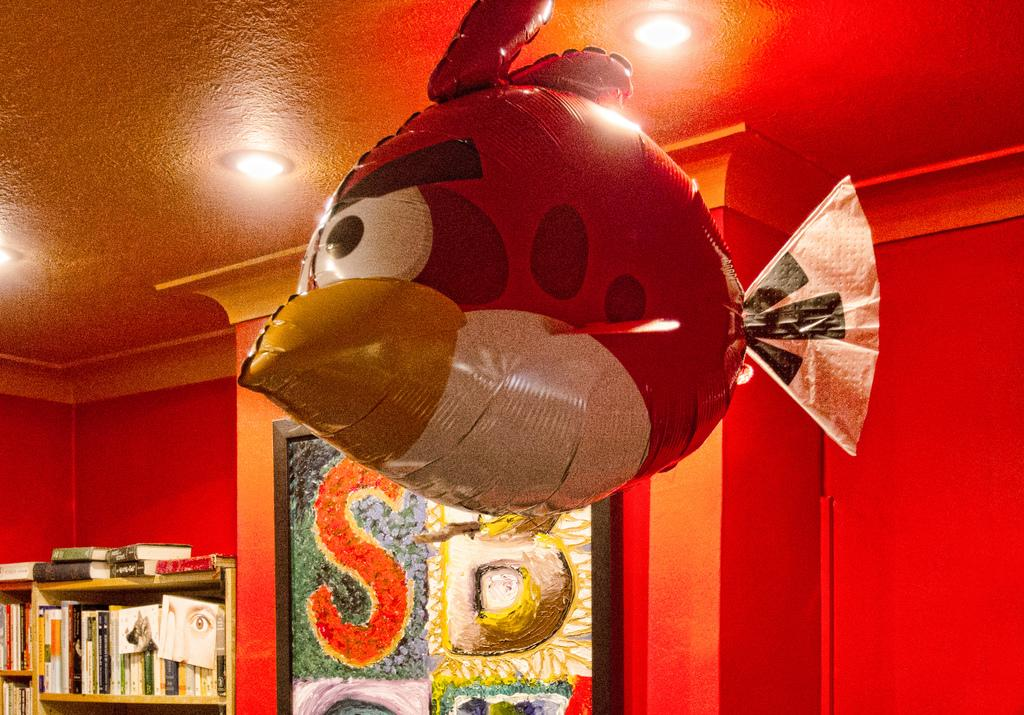What can be seen hanging from the roof in the image? There is an inflatable object hung from the roof in the image. What is visible in the background of the image? There is a wall and a rack in the background of the image. What is stored on the rack in the image? There are many books arranged on the rack. What type of needle is being used to sew the inflatable object in the image? There is no needle present in the image, and the inflatable object is not being sewn. 